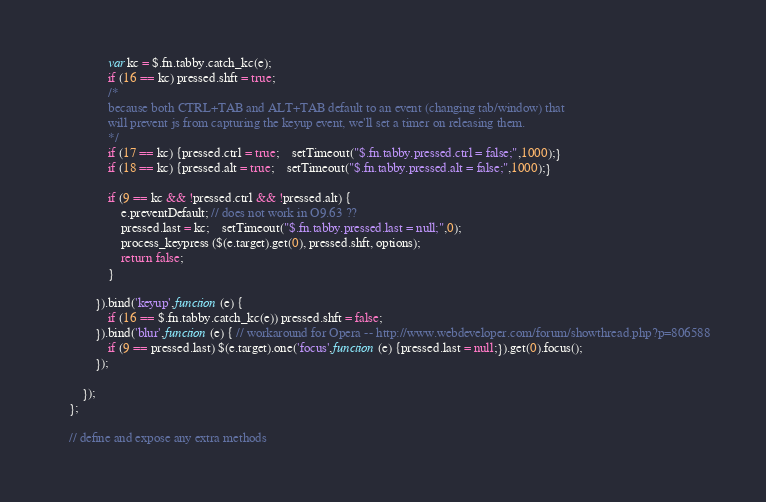Convert code to text. <code><loc_0><loc_0><loc_500><loc_500><_JavaScript_>				var kc = $.fn.tabby.catch_kc(e);
				if (16 == kc) pressed.shft = true;
				/*
				because both CTRL+TAB and ALT+TAB default to an event (changing tab/window) that 
				will prevent js from capturing the keyup event, we'll set a timer on releasing them.
				*/
				if (17 == kc) {pressed.ctrl = true;	setTimeout("$.fn.tabby.pressed.ctrl = false;",1000);}
				if (18 == kc) {pressed.alt = true; 	setTimeout("$.fn.tabby.pressed.alt = false;",1000);}
					
				if (9 == kc && !pressed.ctrl && !pressed.alt) {
					e.preventDefault; // does not work in O9.63 ??
					pressed.last = kc;	setTimeout("$.fn.tabby.pressed.last = null;",0);
					process_keypress ($(e.target).get(0), pressed.shft, options);
					return false;
				}
				
			}).bind('keyup',function (e) {
				if (16 == $.fn.tabby.catch_kc(e)) pressed.shft = false;
			}).bind('blur',function (e) { // workaround for Opera -- http://www.webdeveloper.com/forum/showthread.php?p=806588
				if (9 == pressed.last) $(e.target).one('focus',function (e) {pressed.last = null;}).get(0).focus();
			});
		
		});
	};
	
	// define and expose any extra methods</code> 